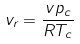Convert formula to latex. <formula><loc_0><loc_0><loc_500><loc_500>v _ { r } = \frac { v p _ { c } } { R T _ { c } }</formula> 